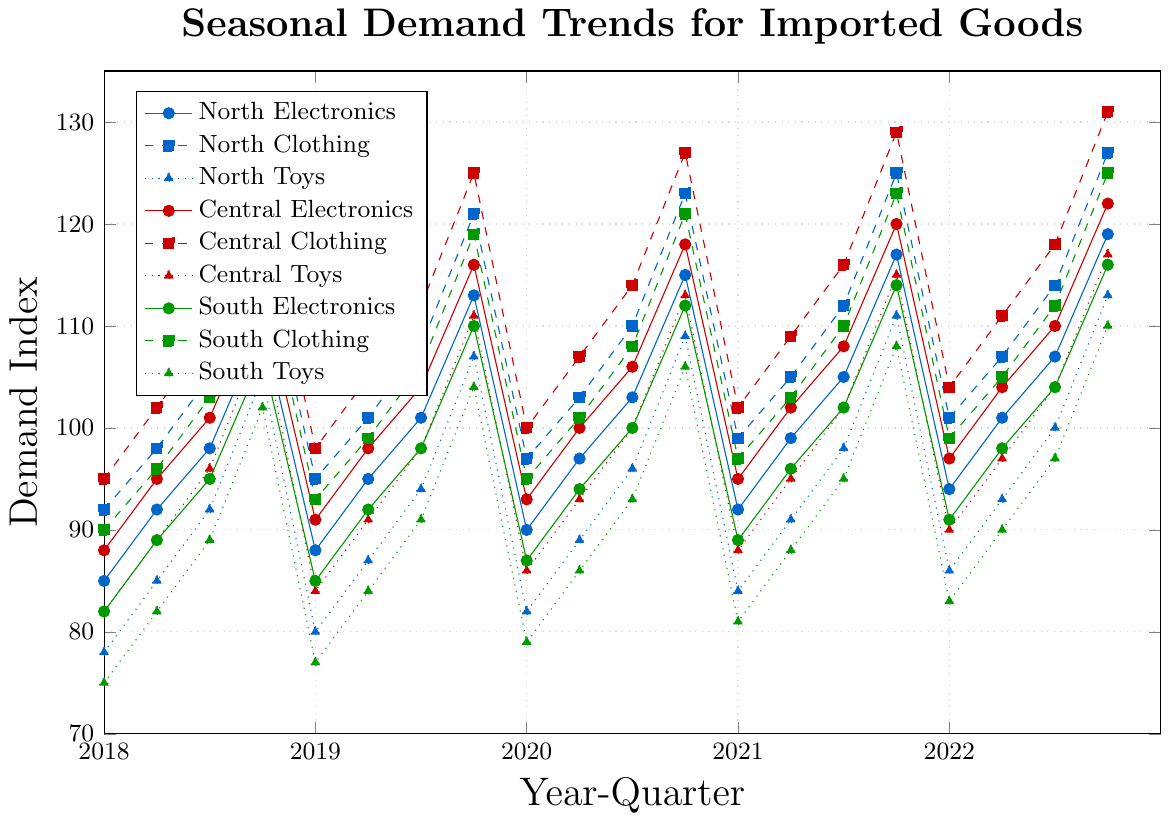Which region shows the highest demand for clothing in Q4 of 2022? To find the answer, look at the demand indices for clothing in Q4 of 2022 for all regions. Central has 131, North has 127, and South has 125. Therefore, the Central region has the highest demand.
Answer: Central Which quarter sees the highest demand for toys in the North during 2018? By examining the demand indices for toys in 2018 in the North region: Q1=78, Q2=85, Q3=92, Q4=105. Q4 has the highest value.
Answer: Q4 How does the demand for Electronics in the Central region in Q2 of 2020 compare to Q2 of 2019? The demand for Electronics in the Central region is 100 in Q2 of 2020 and 98 in Q2 of 2019. So, it is higher in 2020.
Answer: Higher What's the average demand for Toys in the South region across Q3 in all years? The demand indices for Toys in the South during Q3 are: 2018=89, 2019=94, 2020=96, 2021=95, 2022=97. The average is (89+94+96+95+97)/5, which equals 94.2
Answer: 94.2 In which quarter did Electronics in the South region surpass 100 units for the first time? Track when Electronics demand in the South first went above 100. Q3 2020 has a value of 100, and Q4 2020 has 112, surpassing 100. Therefore, Q4 2020 is the first occurrence.
Answer: Q4 2020 What trend is observed in the demand for Clothing in the North region from 2018 to 2022? The demand for Clothing in the North shows an upward trend: 2018 Q1=92, Q2=98, Q3=105, Q4=118; 2019 Q1=95, Q2=101, Q3=108, Q4=121; 2020 Q1=97, Q2=103, Q3=110, Q4=123; 2021 Q1=99, Q2=105, Q3=112, Q4=125; 2022 Q1=101, Q2=107, Q3=114, Q4=127. Each year, the numbers increase steadily.
Answer: Upward trend Compare the demand for Electronics in Q4 across all regions for 2020. Which region has the highest demand? Check the demand for Electronics in Q4 of 2020 across regions: North=115, Central=118, South=112. Central has the highest demand.
Answer: Central What is the difference in the demand for Toys between Q1 and Q4 of 2021 in the Central region? The demand for Toys in Central is 88 in Q1 and 115 in Q4 of 2021. The difference is 115 - 88 = 27.
Answer: 27 